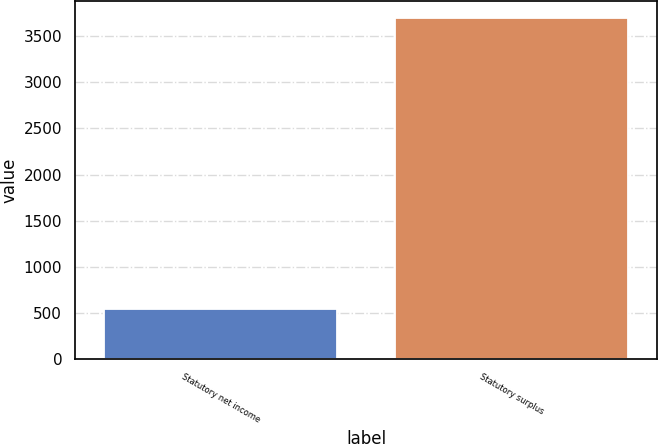Convert chart. <chart><loc_0><loc_0><loc_500><loc_500><bar_chart><fcel>Statutory net income<fcel>Statutory surplus<nl><fcel>540.2<fcel>3695<nl></chart> 